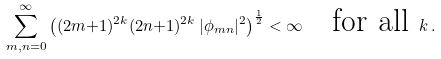<formula> <loc_0><loc_0><loc_500><loc_500>\sum _ { m , n = 0 } ^ { \infty } \left ( ( 2 m { + } 1 ) ^ { 2 k } ( 2 n { + } 1 ) ^ { 2 k } \, | \phi _ { m n } | ^ { 2 } \right ) ^ { \frac { 1 } { 2 } } < \infty \quad \text {for all } k \, .</formula> 